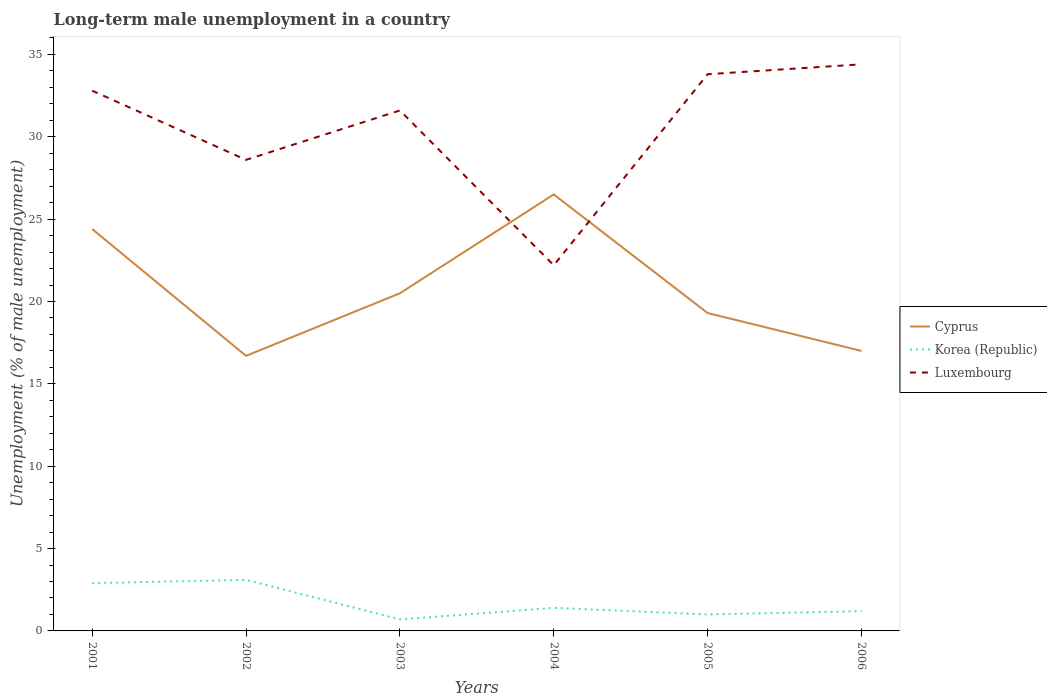Does the line corresponding to Korea (Republic) intersect with the line corresponding to Luxembourg?
Provide a short and direct response. No. Across all years, what is the maximum percentage of long-term unemployed male population in Luxembourg?
Make the answer very short. 22.2. What is the total percentage of long-term unemployed male population in Cyprus in the graph?
Make the answer very short. 1.2. What is the difference between the highest and the second highest percentage of long-term unemployed male population in Luxembourg?
Make the answer very short. 12.2. What is the difference between the highest and the lowest percentage of long-term unemployed male population in Cyprus?
Offer a very short reply. 2. What is the difference between two consecutive major ticks on the Y-axis?
Provide a succinct answer. 5. Are the values on the major ticks of Y-axis written in scientific E-notation?
Ensure brevity in your answer.  No. Where does the legend appear in the graph?
Keep it short and to the point. Center right. How many legend labels are there?
Your response must be concise. 3. What is the title of the graph?
Make the answer very short. Long-term male unemployment in a country. Does "Bosnia and Herzegovina" appear as one of the legend labels in the graph?
Give a very brief answer. No. What is the label or title of the Y-axis?
Offer a very short reply. Unemployment (% of male unemployment). What is the Unemployment (% of male unemployment) in Cyprus in 2001?
Give a very brief answer. 24.4. What is the Unemployment (% of male unemployment) of Korea (Republic) in 2001?
Your answer should be compact. 2.9. What is the Unemployment (% of male unemployment) of Luxembourg in 2001?
Keep it short and to the point. 32.8. What is the Unemployment (% of male unemployment) of Cyprus in 2002?
Ensure brevity in your answer.  16.7. What is the Unemployment (% of male unemployment) in Korea (Republic) in 2002?
Ensure brevity in your answer.  3.1. What is the Unemployment (% of male unemployment) of Luxembourg in 2002?
Keep it short and to the point. 28.6. What is the Unemployment (% of male unemployment) of Korea (Republic) in 2003?
Your answer should be very brief. 0.7. What is the Unemployment (% of male unemployment) of Luxembourg in 2003?
Your answer should be compact. 31.6. What is the Unemployment (% of male unemployment) in Cyprus in 2004?
Your response must be concise. 26.5. What is the Unemployment (% of male unemployment) of Korea (Republic) in 2004?
Offer a very short reply. 1.4. What is the Unemployment (% of male unemployment) of Luxembourg in 2004?
Give a very brief answer. 22.2. What is the Unemployment (% of male unemployment) of Cyprus in 2005?
Offer a very short reply. 19.3. What is the Unemployment (% of male unemployment) of Luxembourg in 2005?
Your answer should be compact. 33.8. What is the Unemployment (% of male unemployment) of Korea (Republic) in 2006?
Your answer should be very brief. 1.2. What is the Unemployment (% of male unemployment) of Luxembourg in 2006?
Your answer should be very brief. 34.4. Across all years, what is the maximum Unemployment (% of male unemployment) in Cyprus?
Offer a very short reply. 26.5. Across all years, what is the maximum Unemployment (% of male unemployment) of Korea (Republic)?
Provide a succinct answer. 3.1. Across all years, what is the maximum Unemployment (% of male unemployment) of Luxembourg?
Give a very brief answer. 34.4. Across all years, what is the minimum Unemployment (% of male unemployment) of Cyprus?
Ensure brevity in your answer.  16.7. Across all years, what is the minimum Unemployment (% of male unemployment) in Korea (Republic)?
Keep it short and to the point. 0.7. Across all years, what is the minimum Unemployment (% of male unemployment) of Luxembourg?
Ensure brevity in your answer.  22.2. What is the total Unemployment (% of male unemployment) in Cyprus in the graph?
Offer a very short reply. 124.4. What is the total Unemployment (% of male unemployment) in Luxembourg in the graph?
Provide a succinct answer. 183.4. What is the difference between the Unemployment (% of male unemployment) in Korea (Republic) in 2001 and that in 2002?
Your answer should be compact. -0.2. What is the difference between the Unemployment (% of male unemployment) of Luxembourg in 2001 and that in 2002?
Your answer should be very brief. 4.2. What is the difference between the Unemployment (% of male unemployment) of Cyprus in 2001 and that in 2003?
Keep it short and to the point. 3.9. What is the difference between the Unemployment (% of male unemployment) in Luxembourg in 2001 and that in 2003?
Your answer should be compact. 1.2. What is the difference between the Unemployment (% of male unemployment) of Korea (Republic) in 2001 and that in 2004?
Keep it short and to the point. 1.5. What is the difference between the Unemployment (% of male unemployment) of Luxembourg in 2001 and that in 2005?
Keep it short and to the point. -1. What is the difference between the Unemployment (% of male unemployment) of Cyprus in 2001 and that in 2006?
Keep it short and to the point. 7.4. What is the difference between the Unemployment (% of male unemployment) in Luxembourg in 2001 and that in 2006?
Make the answer very short. -1.6. What is the difference between the Unemployment (% of male unemployment) in Korea (Republic) in 2002 and that in 2003?
Provide a short and direct response. 2.4. What is the difference between the Unemployment (% of male unemployment) in Luxembourg in 2002 and that in 2003?
Your answer should be very brief. -3. What is the difference between the Unemployment (% of male unemployment) of Korea (Republic) in 2002 and that in 2004?
Your response must be concise. 1.7. What is the difference between the Unemployment (% of male unemployment) of Luxembourg in 2002 and that in 2004?
Your answer should be very brief. 6.4. What is the difference between the Unemployment (% of male unemployment) in Luxembourg in 2002 and that in 2005?
Give a very brief answer. -5.2. What is the difference between the Unemployment (% of male unemployment) in Cyprus in 2002 and that in 2006?
Your response must be concise. -0.3. What is the difference between the Unemployment (% of male unemployment) in Korea (Republic) in 2002 and that in 2006?
Your answer should be compact. 1.9. What is the difference between the Unemployment (% of male unemployment) in Korea (Republic) in 2003 and that in 2004?
Ensure brevity in your answer.  -0.7. What is the difference between the Unemployment (% of male unemployment) in Cyprus in 2003 and that in 2005?
Give a very brief answer. 1.2. What is the difference between the Unemployment (% of male unemployment) in Korea (Republic) in 2003 and that in 2005?
Offer a terse response. -0.3. What is the difference between the Unemployment (% of male unemployment) in Luxembourg in 2003 and that in 2005?
Your answer should be very brief. -2.2. What is the difference between the Unemployment (% of male unemployment) in Cyprus in 2003 and that in 2006?
Provide a succinct answer. 3.5. What is the difference between the Unemployment (% of male unemployment) in Korea (Republic) in 2003 and that in 2006?
Keep it short and to the point. -0.5. What is the difference between the Unemployment (% of male unemployment) in Luxembourg in 2003 and that in 2006?
Give a very brief answer. -2.8. What is the difference between the Unemployment (% of male unemployment) in Cyprus in 2004 and that in 2005?
Provide a succinct answer. 7.2. What is the difference between the Unemployment (% of male unemployment) in Korea (Republic) in 2004 and that in 2005?
Ensure brevity in your answer.  0.4. What is the difference between the Unemployment (% of male unemployment) of Cyprus in 2005 and that in 2006?
Your answer should be very brief. 2.3. What is the difference between the Unemployment (% of male unemployment) of Korea (Republic) in 2005 and that in 2006?
Your response must be concise. -0.2. What is the difference between the Unemployment (% of male unemployment) of Luxembourg in 2005 and that in 2006?
Provide a succinct answer. -0.6. What is the difference between the Unemployment (% of male unemployment) in Cyprus in 2001 and the Unemployment (% of male unemployment) in Korea (Republic) in 2002?
Offer a terse response. 21.3. What is the difference between the Unemployment (% of male unemployment) of Korea (Republic) in 2001 and the Unemployment (% of male unemployment) of Luxembourg in 2002?
Your response must be concise. -25.7. What is the difference between the Unemployment (% of male unemployment) of Cyprus in 2001 and the Unemployment (% of male unemployment) of Korea (Republic) in 2003?
Keep it short and to the point. 23.7. What is the difference between the Unemployment (% of male unemployment) of Cyprus in 2001 and the Unemployment (% of male unemployment) of Luxembourg in 2003?
Your answer should be compact. -7.2. What is the difference between the Unemployment (% of male unemployment) in Korea (Republic) in 2001 and the Unemployment (% of male unemployment) in Luxembourg in 2003?
Give a very brief answer. -28.7. What is the difference between the Unemployment (% of male unemployment) of Cyprus in 2001 and the Unemployment (% of male unemployment) of Luxembourg in 2004?
Ensure brevity in your answer.  2.2. What is the difference between the Unemployment (% of male unemployment) in Korea (Republic) in 2001 and the Unemployment (% of male unemployment) in Luxembourg in 2004?
Make the answer very short. -19.3. What is the difference between the Unemployment (% of male unemployment) in Cyprus in 2001 and the Unemployment (% of male unemployment) in Korea (Republic) in 2005?
Keep it short and to the point. 23.4. What is the difference between the Unemployment (% of male unemployment) of Cyprus in 2001 and the Unemployment (% of male unemployment) of Luxembourg in 2005?
Offer a terse response. -9.4. What is the difference between the Unemployment (% of male unemployment) in Korea (Republic) in 2001 and the Unemployment (% of male unemployment) in Luxembourg in 2005?
Keep it short and to the point. -30.9. What is the difference between the Unemployment (% of male unemployment) in Cyprus in 2001 and the Unemployment (% of male unemployment) in Korea (Republic) in 2006?
Your answer should be compact. 23.2. What is the difference between the Unemployment (% of male unemployment) in Korea (Republic) in 2001 and the Unemployment (% of male unemployment) in Luxembourg in 2006?
Give a very brief answer. -31.5. What is the difference between the Unemployment (% of male unemployment) in Cyprus in 2002 and the Unemployment (% of male unemployment) in Korea (Republic) in 2003?
Make the answer very short. 16. What is the difference between the Unemployment (% of male unemployment) of Cyprus in 2002 and the Unemployment (% of male unemployment) of Luxembourg in 2003?
Your answer should be compact. -14.9. What is the difference between the Unemployment (% of male unemployment) in Korea (Republic) in 2002 and the Unemployment (% of male unemployment) in Luxembourg in 2003?
Keep it short and to the point. -28.5. What is the difference between the Unemployment (% of male unemployment) of Korea (Republic) in 2002 and the Unemployment (% of male unemployment) of Luxembourg in 2004?
Ensure brevity in your answer.  -19.1. What is the difference between the Unemployment (% of male unemployment) in Cyprus in 2002 and the Unemployment (% of male unemployment) in Luxembourg in 2005?
Provide a short and direct response. -17.1. What is the difference between the Unemployment (% of male unemployment) of Korea (Republic) in 2002 and the Unemployment (% of male unemployment) of Luxembourg in 2005?
Ensure brevity in your answer.  -30.7. What is the difference between the Unemployment (% of male unemployment) in Cyprus in 2002 and the Unemployment (% of male unemployment) in Luxembourg in 2006?
Offer a very short reply. -17.7. What is the difference between the Unemployment (% of male unemployment) in Korea (Republic) in 2002 and the Unemployment (% of male unemployment) in Luxembourg in 2006?
Make the answer very short. -31.3. What is the difference between the Unemployment (% of male unemployment) of Korea (Republic) in 2003 and the Unemployment (% of male unemployment) of Luxembourg in 2004?
Keep it short and to the point. -21.5. What is the difference between the Unemployment (% of male unemployment) in Korea (Republic) in 2003 and the Unemployment (% of male unemployment) in Luxembourg in 2005?
Offer a very short reply. -33.1. What is the difference between the Unemployment (% of male unemployment) in Cyprus in 2003 and the Unemployment (% of male unemployment) in Korea (Republic) in 2006?
Make the answer very short. 19.3. What is the difference between the Unemployment (% of male unemployment) in Cyprus in 2003 and the Unemployment (% of male unemployment) in Luxembourg in 2006?
Provide a short and direct response. -13.9. What is the difference between the Unemployment (% of male unemployment) of Korea (Republic) in 2003 and the Unemployment (% of male unemployment) of Luxembourg in 2006?
Provide a succinct answer. -33.7. What is the difference between the Unemployment (% of male unemployment) in Cyprus in 2004 and the Unemployment (% of male unemployment) in Korea (Republic) in 2005?
Provide a succinct answer. 25.5. What is the difference between the Unemployment (% of male unemployment) in Cyprus in 2004 and the Unemployment (% of male unemployment) in Luxembourg in 2005?
Keep it short and to the point. -7.3. What is the difference between the Unemployment (% of male unemployment) of Korea (Republic) in 2004 and the Unemployment (% of male unemployment) of Luxembourg in 2005?
Give a very brief answer. -32.4. What is the difference between the Unemployment (% of male unemployment) of Cyprus in 2004 and the Unemployment (% of male unemployment) of Korea (Republic) in 2006?
Your answer should be very brief. 25.3. What is the difference between the Unemployment (% of male unemployment) in Korea (Republic) in 2004 and the Unemployment (% of male unemployment) in Luxembourg in 2006?
Your response must be concise. -33. What is the difference between the Unemployment (% of male unemployment) in Cyprus in 2005 and the Unemployment (% of male unemployment) in Korea (Republic) in 2006?
Your response must be concise. 18.1. What is the difference between the Unemployment (% of male unemployment) of Cyprus in 2005 and the Unemployment (% of male unemployment) of Luxembourg in 2006?
Offer a terse response. -15.1. What is the difference between the Unemployment (% of male unemployment) in Korea (Republic) in 2005 and the Unemployment (% of male unemployment) in Luxembourg in 2006?
Offer a very short reply. -33.4. What is the average Unemployment (% of male unemployment) of Cyprus per year?
Give a very brief answer. 20.73. What is the average Unemployment (% of male unemployment) of Korea (Republic) per year?
Provide a succinct answer. 1.72. What is the average Unemployment (% of male unemployment) in Luxembourg per year?
Offer a very short reply. 30.57. In the year 2001, what is the difference between the Unemployment (% of male unemployment) in Cyprus and Unemployment (% of male unemployment) in Luxembourg?
Your answer should be very brief. -8.4. In the year 2001, what is the difference between the Unemployment (% of male unemployment) of Korea (Republic) and Unemployment (% of male unemployment) of Luxembourg?
Keep it short and to the point. -29.9. In the year 2002, what is the difference between the Unemployment (% of male unemployment) in Cyprus and Unemployment (% of male unemployment) in Korea (Republic)?
Ensure brevity in your answer.  13.6. In the year 2002, what is the difference between the Unemployment (% of male unemployment) of Cyprus and Unemployment (% of male unemployment) of Luxembourg?
Your answer should be compact. -11.9. In the year 2002, what is the difference between the Unemployment (% of male unemployment) of Korea (Republic) and Unemployment (% of male unemployment) of Luxembourg?
Provide a short and direct response. -25.5. In the year 2003, what is the difference between the Unemployment (% of male unemployment) of Cyprus and Unemployment (% of male unemployment) of Korea (Republic)?
Offer a terse response. 19.8. In the year 2003, what is the difference between the Unemployment (% of male unemployment) of Korea (Republic) and Unemployment (% of male unemployment) of Luxembourg?
Offer a terse response. -30.9. In the year 2004, what is the difference between the Unemployment (% of male unemployment) in Cyprus and Unemployment (% of male unemployment) in Korea (Republic)?
Keep it short and to the point. 25.1. In the year 2004, what is the difference between the Unemployment (% of male unemployment) of Cyprus and Unemployment (% of male unemployment) of Luxembourg?
Provide a short and direct response. 4.3. In the year 2004, what is the difference between the Unemployment (% of male unemployment) of Korea (Republic) and Unemployment (% of male unemployment) of Luxembourg?
Give a very brief answer. -20.8. In the year 2005, what is the difference between the Unemployment (% of male unemployment) in Cyprus and Unemployment (% of male unemployment) in Luxembourg?
Provide a short and direct response. -14.5. In the year 2005, what is the difference between the Unemployment (% of male unemployment) in Korea (Republic) and Unemployment (% of male unemployment) in Luxembourg?
Offer a terse response. -32.8. In the year 2006, what is the difference between the Unemployment (% of male unemployment) of Cyprus and Unemployment (% of male unemployment) of Luxembourg?
Your answer should be compact. -17.4. In the year 2006, what is the difference between the Unemployment (% of male unemployment) in Korea (Republic) and Unemployment (% of male unemployment) in Luxembourg?
Provide a short and direct response. -33.2. What is the ratio of the Unemployment (% of male unemployment) in Cyprus in 2001 to that in 2002?
Your response must be concise. 1.46. What is the ratio of the Unemployment (% of male unemployment) of Korea (Republic) in 2001 to that in 2002?
Your answer should be compact. 0.94. What is the ratio of the Unemployment (% of male unemployment) in Luxembourg in 2001 to that in 2002?
Your answer should be compact. 1.15. What is the ratio of the Unemployment (% of male unemployment) of Cyprus in 2001 to that in 2003?
Provide a succinct answer. 1.19. What is the ratio of the Unemployment (% of male unemployment) in Korea (Republic) in 2001 to that in 2003?
Your response must be concise. 4.14. What is the ratio of the Unemployment (% of male unemployment) in Luxembourg in 2001 to that in 2003?
Your response must be concise. 1.04. What is the ratio of the Unemployment (% of male unemployment) of Cyprus in 2001 to that in 2004?
Offer a terse response. 0.92. What is the ratio of the Unemployment (% of male unemployment) in Korea (Republic) in 2001 to that in 2004?
Offer a terse response. 2.07. What is the ratio of the Unemployment (% of male unemployment) in Luxembourg in 2001 to that in 2004?
Provide a succinct answer. 1.48. What is the ratio of the Unemployment (% of male unemployment) of Cyprus in 2001 to that in 2005?
Your response must be concise. 1.26. What is the ratio of the Unemployment (% of male unemployment) of Korea (Republic) in 2001 to that in 2005?
Ensure brevity in your answer.  2.9. What is the ratio of the Unemployment (% of male unemployment) of Luxembourg in 2001 to that in 2005?
Offer a very short reply. 0.97. What is the ratio of the Unemployment (% of male unemployment) of Cyprus in 2001 to that in 2006?
Provide a succinct answer. 1.44. What is the ratio of the Unemployment (% of male unemployment) of Korea (Republic) in 2001 to that in 2006?
Give a very brief answer. 2.42. What is the ratio of the Unemployment (% of male unemployment) of Luxembourg in 2001 to that in 2006?
Offer a very short reply. 0.95. What is the ratio of the Unemployment (% of male unemployment) in Cyprus in 2002 to that in 2003?
Give a very brief answer. 0.81. What is the ratio of the Unemployment (% of male unemployment) in Korea (Republic) in 2002 to that in 2003?
Provide a succinct answer. 4.43. What is the ratio of the Unemployment (% of male unemployment) of Luxembourg in 2002 to that in 2003?
Your answer should be very brief. 0.91. What is the ratio of the Unemployment (% of male unemployment) in Cyprus in 2002 to that in 2004?
Provide a succinct answer. 0.63. What is the ratio of the Unemployment (% of male unemployment) of Korea (Republic) in 2002 to that in 2004?
Your response must be concise. 2.21. What is the ratio of the Unemployment (% of male unemployment) of Luxembourg in 2002 to that in 2004?
Keep it short and to the point. 1.29. What is the ratio of the Unemployment (% of male unemployment) of Cyprus in 2002 to that in 2005?
Your answer should be very brief. 0.87. What is the ratio of the Unemployment (% of male unemployment) in Korea (Republic) in 2002 to that in 2005?
Your answer should be very brief. 3.1. What is the ratio of the Unemployment (% of male unemployment) of Luxembourg in 2002 to that in 2005?
Your answer should be very brief. 0.85. What is the ratio of the Unemployment (% of male unemployment) of Cyprus in 2002 to that in 2006?
Ensure brevity in your answer.  0.98. What is the ratio of the Unemployment (% of male unemployment) in Korea (Republic) in 2002 to that in 2006?
Give a very brief answer. 2.58. What is the ratio of the Unemployment (% of male unemployment) of Luxembourg in 2002 to that in 2006?
Your answer should be very brief. 0.83. What is the ratio of the Unemployment (% of male unemployment) in Cyprus in 2003 to that in 2004?
Provide a succinct answer. 0.77. What is the ratio of the Unemployment (% of male unemployment) in Luxembourg in 2003 to that in 2004?
Ensure brevity in your answer.  1.42. What is the ratio of the Unemployment (% of male unemployment) of Cyprus in 2003 to that in 2005?
Make the answer very short. 1.06. What is the ratio of the Unemployment (% of male unemployment) of Korea (Republic) in 2003 to that in 2005?
Provide a succinct answer. 0.7. What is the ratio of the Unemployment (% of male unemployment) in Luxembourg in 2003 to that in 2005?
Offer a terse response. 0.93. What is the ratio of the Unemployment (% of male unemployment) of Cyprus in 2003 to that in 2006?
Offer a very short reply. 1.21. What is the ratio of the Unemployment (% of male unemployment) of Korea (Republic) in 2003 to that in 2006?
Offer a very short reply. 0.58. What is the ratio of the Unemployment (% of male unemployment) in Luxembourg in 2003 to that in 2006?
Offer a terse response. 0.92. What is the ratio of the Unemployment (% of male unemployment) of Cyprus in 2004 to that in 2005?
Offer a very short reply. 1.37. What is the ratio of the Unemployment (% of male unemployment) in Luxembourg in 2004 to that in 2005?
Your response must be concise. 0.66. What is the ratio of the Unemployment (% of male unemployment) of Cyprus in 2004 to that in 2006?
Keep it short and to the point. 1.56. What is the ratio of the Unemployment (% of male unemployment) in Luxembourg in 2004 to that in 2006?
Keep it short and to the point. 0.65. What is the ratio of the Unemployment (% of male unemployment) in Cyprus in 2005 to that in 2006?
Offer a very short reply. 1.14. What is the ratio of the Unemployment (% of male unemployment) in Korea (Republic) in 2005 to that in 2006?
Ensure brevity in your answer.  0.83. What is the ratio of the Unemployment (% of male unemployment) of Luxembourg in 2005 to that in 2006?
Give a very brief answer. 0.98. What is the difference between the highest and the second highest Unemployment (% of male unemployment) in Korea (Republic)?
Your answer should be very brief. 0.2. What is the difference between the highest and the second highest Unemployment (% of male unemployment) of Luxembourg?
Your answer should be very brief. 0.6. What is the difference between the highest and the lowest Unemployment (% of male unemployment) of Luxembourg?
Your answer should be very brief. 12.2. 